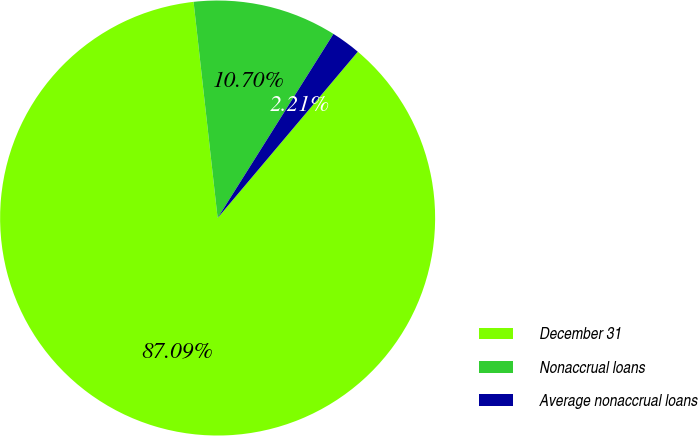Convert chart to OTSL. <chart><loc_0><loc_0><loc_500><loc_500><pie_chart><fcel>December 31<fcel>Nonaccrual loans<fcel>Average nonaccrual loans<nl><fcel>87.09%<fcel>10.7%<fcel>2.21%<nl></chart> 